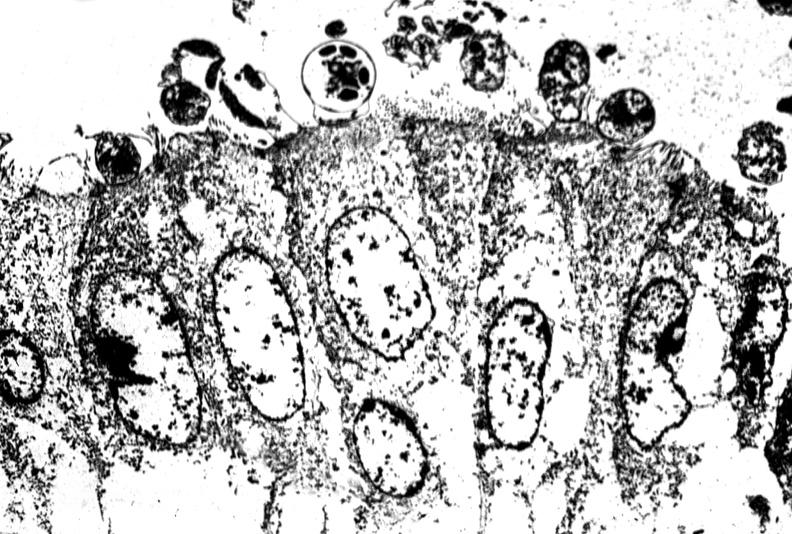what is present?
Answer the question using a single word or phrase. Gastrointestinal 